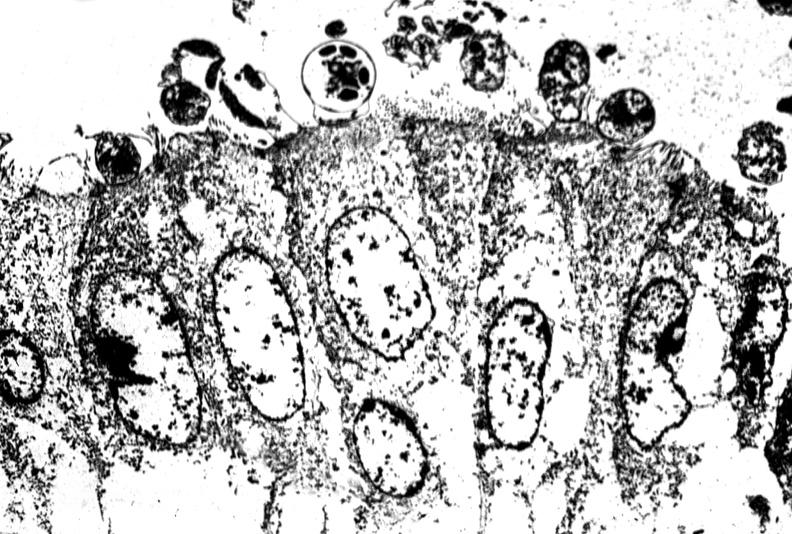what is present?
Answer the question using a single word or phrase. Gastrointestinal 